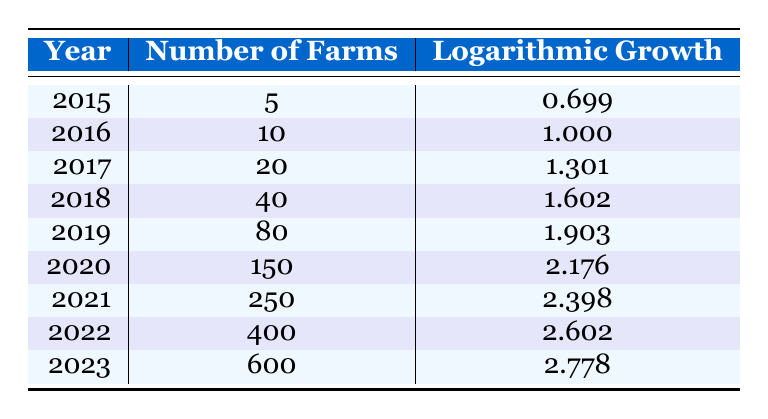What was the logarithmic growth value for the year 2019? From the table, under the "Logarithmic Growth" column for the year 2019, the value is directly listed as 1.903.
Answer: 1.903 How many farms were recorded in 2021? The table shows that for the year 2021, the "Number of Farms" is 250, which is explicitly stated in the corresponding column.
Answer: 250 What is the average number of farms from 2015 to 2023? To calculate the average, first, sum the number of farms from 2015 (5), 2016 (10), 2017 (20), 2018 (40), 2019 (80), 2020 (150), 2021 (250), 2022 (400), and 2023 (600). The total is 5 + 10 + 20 + 40 + 80 + 150 + 250 + 400 + 600 = 1555. There are 9 years, so the average is 1555 / 9 = 173.89, approximately 174 when rounded.
Answer: 174 Did the number of farms grow each year from 2015 to 2023? Yes, examining the "Number of Farms" column; it increases every year: from 5 in 2015 to 600 in 2023, confirming a consistent growth pattern.
Answer: Yes What was the total logarithmic growth over the entire period from 2015 to 2023? To find the total logarithmic growth, sum each year's logarithmic growth values: 0.699 (2015) + 1.000 (2016) + 1.301 (2017) + 1.602 (2018) + 1.903 (2019) + 2.176 (2020) + 2.398 (2021) + 2.602 (2022) + 2.778 (2023) = 15.059. Thus, the total logarithmic growth is 15.059.
Answer: 15.059 What year experienced the largest increase in the number of farms compared to the previous year? To find the largest annual increase, calculate the difference in the number of farms between consecutive years. The largest increase occurs between 2020 (150 farms) and 2021 (250 farms), showing an increase of 100 farms.
Answer: 2021 What was the logarithmic growth trend from 2015 to 2023? The logarithmic growth trend shows an upward trajectory; the values demonstrate consistent growth each year, indicating that the adoption of sustainable farming practices significantly improved over this period.
Answer: Upward trend What was the number of farms in the year with the maximum logarithmic growth? The maximum logarithmic growth value appears in the year 2023 with a value of 2.778. As shown in the table, this correlates with 600 farms.
Answer: 600 